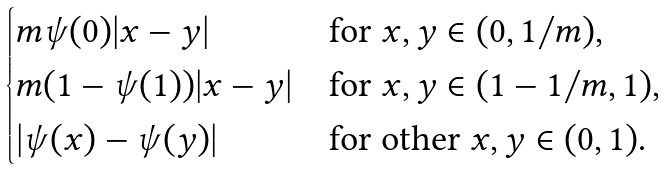<formula> <loc_0><loc_0><loc_500><loc_500>\begin{cases} m \psi ( 0 ) | x - y | & \text {for $x,y\in(0,1/m)$} , \\ m ( 1 - \psi ( 1 ) ) | x - y | & \text {for $x,y\in(1-1/m,1)$} , \\ | \psi ( x ) - \psi ( y ) | & \text {for other $x,y\in(0,1)$} . \end{cases}</formula> 